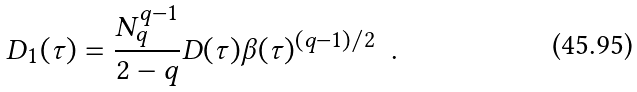<formula> <loc_0><loc_0><loc_500><loc_500>D _ { 1 } ( \tau ) = \frac { N _ { q } ^ { q - 1 } } { 2 - q } D ( \tau ) \beta ( \tau ) ^ { ( q - 1 ) / 2 } \ \ .</formula> 